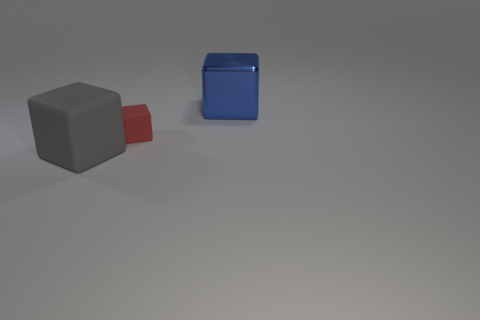Subtract 3 cubes. How many cubes are left? 0 Subtract all gray blocks. How many blocks are left? 2 Add 2 brown metallic blocks. How many objects exist? 5 Subtract all gray blocks. How many blocks are left? 2 Subtract 0 green cubes. How many objects are left? 3 Subtract all yellow blocks. Subtract all yellow balls. How many blocks are left? 3 Subtract all purple spheres. How many gray cubes are left? 1 Subtract all big blue objects. Subtract all metallic blocks. How many objects are left? 1 Add 3 red blocks. How many red blocks are left? 4 Add 1 red matte things. How many red matte things exist? 2 